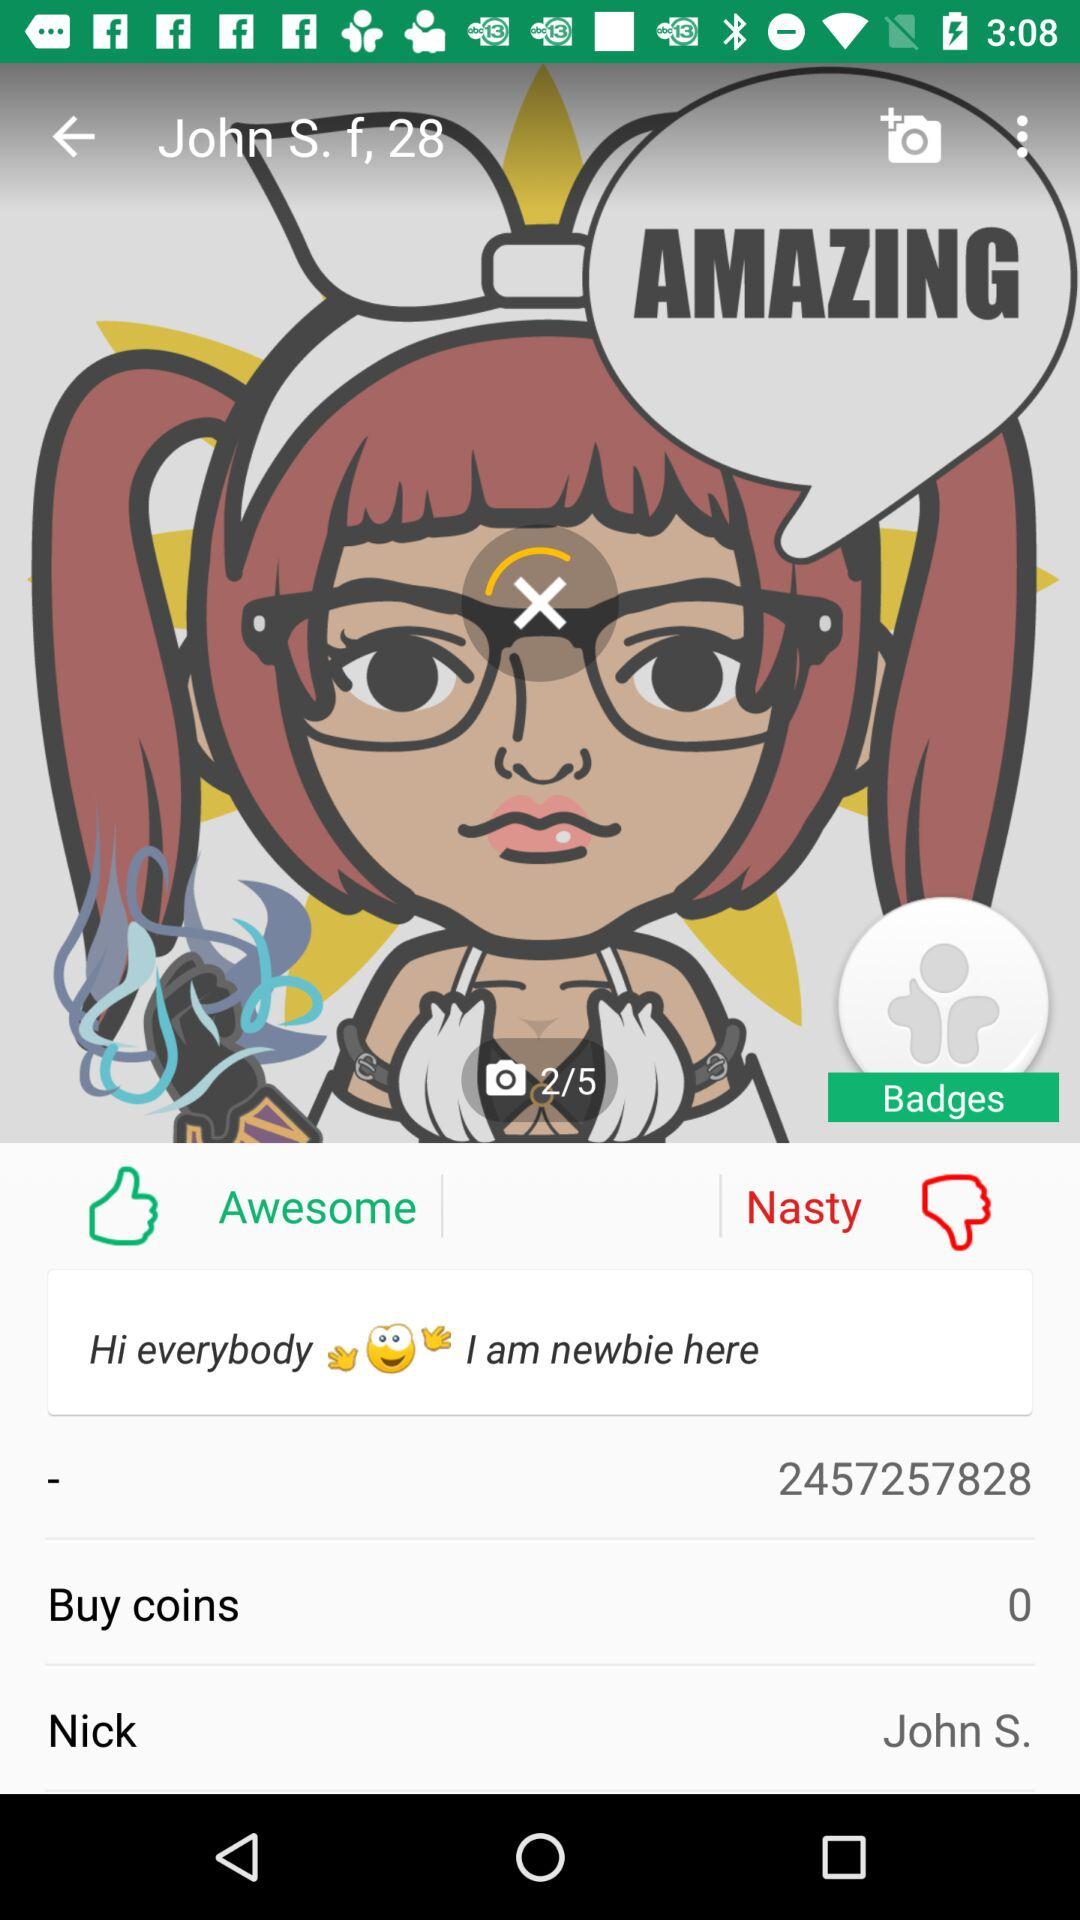How many coins are there? There are 0 coins. 